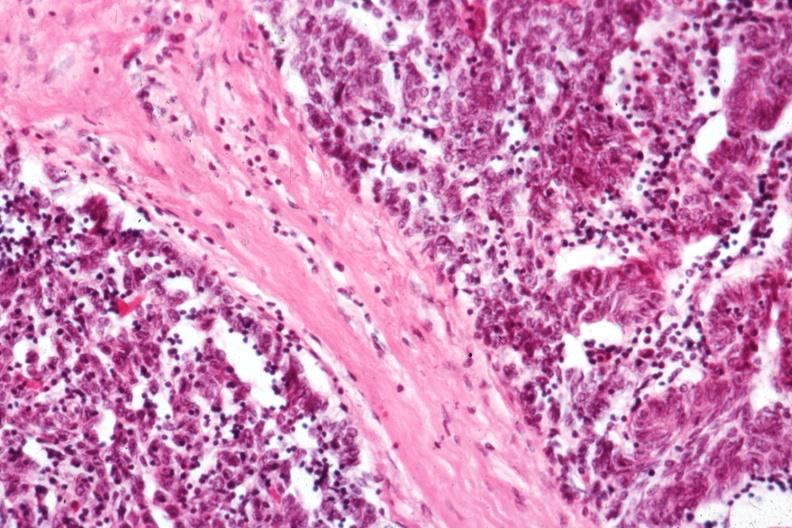s thymoma present?
Answer the question using a single word or phrase. Yes 